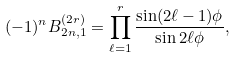<formula> <loc_0><loc_0><loc_500><loc_500>( - 1 ) ^ { n } B _ { 2 n , 1 } ^ { ( 2 r ) } = \prod _ { \ell = 1 } ^ { r } \frac { \sin ( 2 \ell - 1 ) \phi } { \sin 2 \ell \phi } ,</formula> 